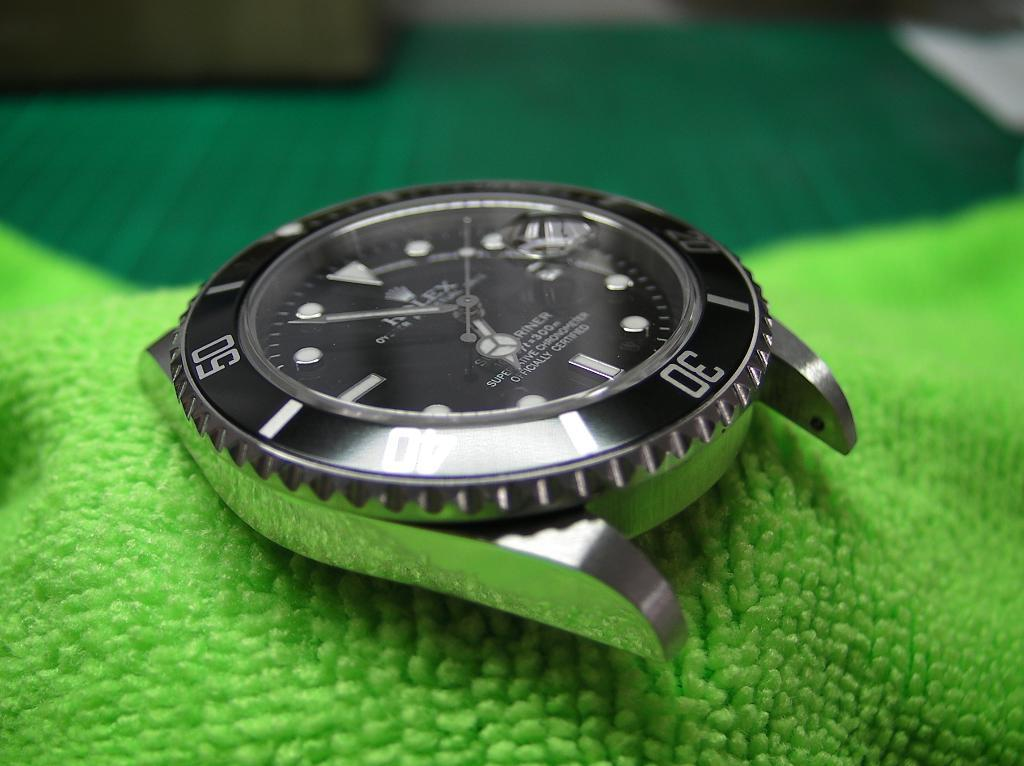Provide a one-sentence caption for the provided image. A silver Rolex watch face sits on a green cloth. 